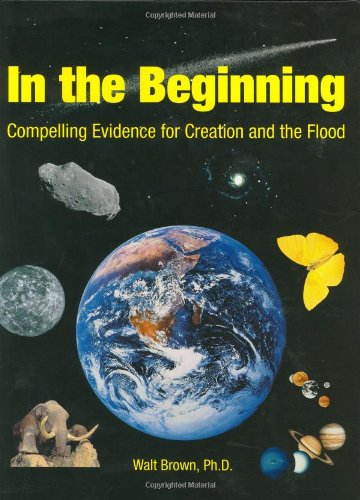How has this book been received by the scientific community? This book has been met with mixed reactions; while it's valued in creationist circles for its detailed arguments, many in the mainstream scientific community critice its interpretations and allege misrepresentation of scientific data. 